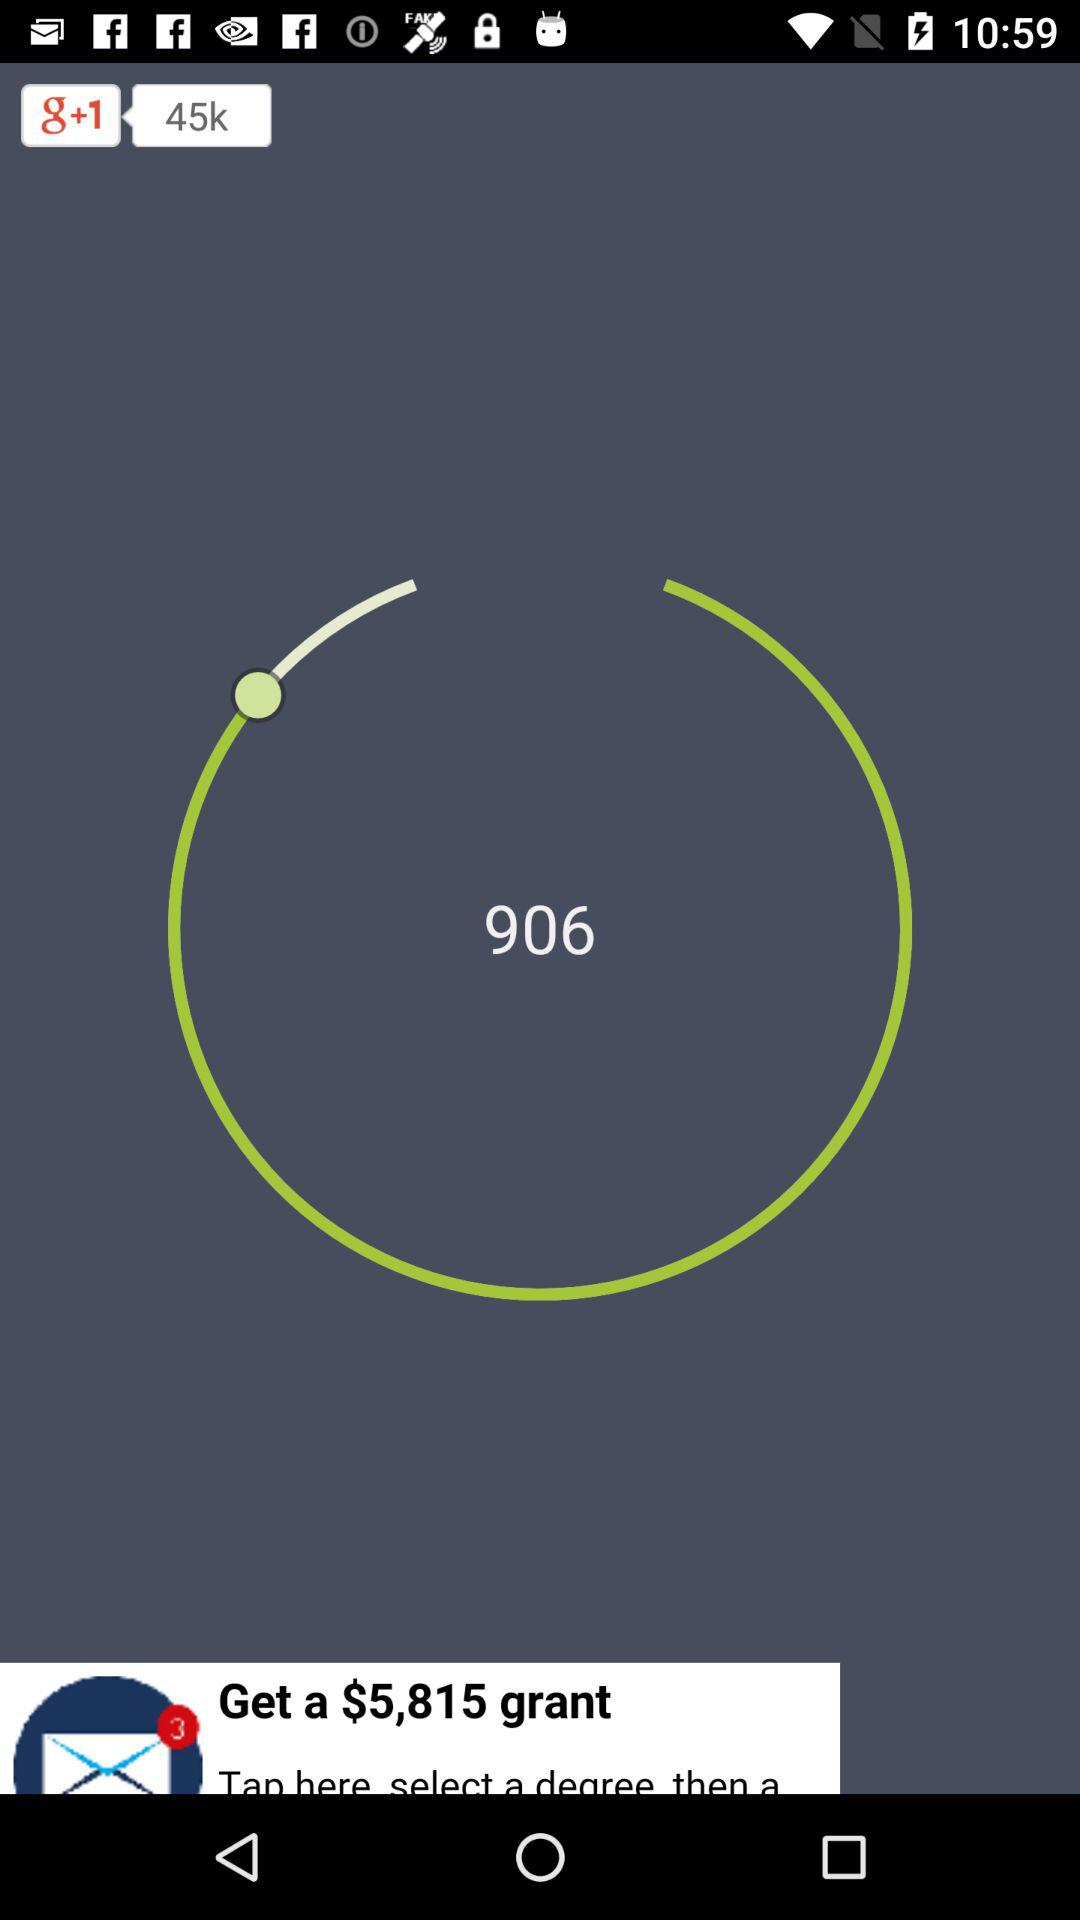How many likes on "g+1"? There are 45k likes. 